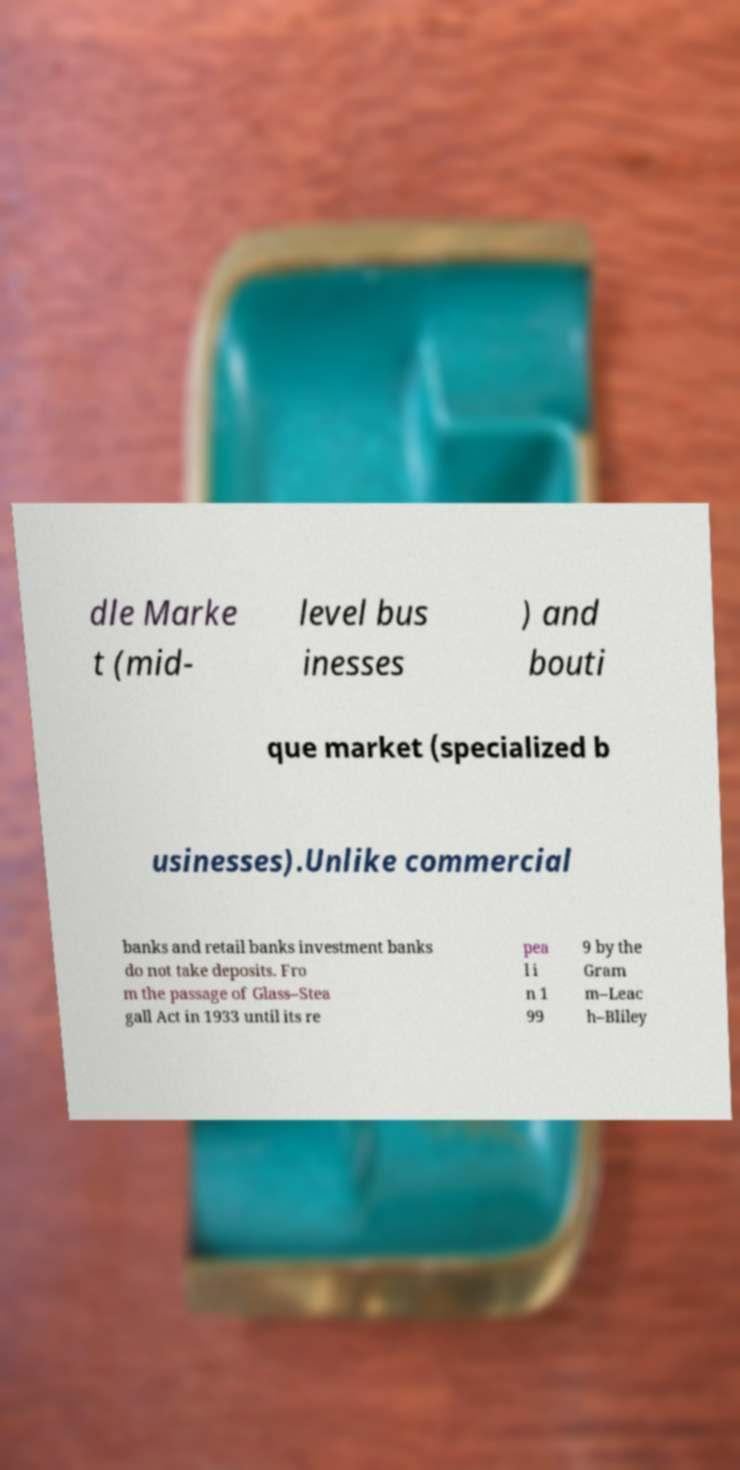There's text embedded in this image that I need extracted. Can you transcribe it verbatim? dle Marke t (mid- level bus inesses ) and bouti que market (specialized b usinesses).Unlike commercial banks and retail banks investment banks do not take deposits. Fro m the passage of Glass–Stea gall Act in 1933 until its re pea l i n 1 99 9 by the Gram m–Leac h–Bliley 